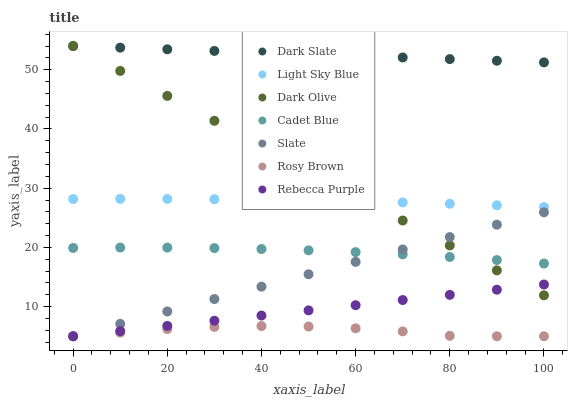Does Rosy Brown have the minimum area under the curve?
Answer yes or no. Yes. Does Dark Slate have the maximum area under the curve?
Answer yes or no. Yes. Does Slate have the minimum area under the curve?
Answer yes or no. No. Does Slate have the maximum area under the curve?
Answer yes or no. No. Is Slate the smoothest?
Answer yes or no. Yes. Is Rosy Brown the roughest?
Answer yes or no. Yes. Is Dark Olive the smoothest?
Answer yes or no. No. Is Dark Olive the roughest?
Answer yes or no. No. Does Slate have the lowest value?
Answer yes or no. Yes. Does Dark Olive have the lowest value?
Answer yes or no. No. Does Dark Slate have the highest value?
Answer yes or no. Yes. Does Slate have the highest value?
Answer yes or no. No. Is Cadet Blue less than Light Sky Blue?
Answer yes or no. Yes. Is Light Sky Blue greater than Slate?
Answer yes or no. Yes. Does Dark Olive intersect Slate?
Answer yes or no. Yes. Is Dark Olive less than Slate?
Answer yes or no. No. Is Dark Olive greater than Slate?
Answer yes or no. No. Does Cadet Blue intersect Light Sky Blue?
Answer yes or no. No. 